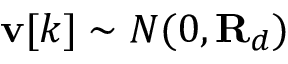<formula> <loc_0><loc_0><loc_500><loc_500>v [ k ] \sim N ( 0 , R _ { d } )</formula> 